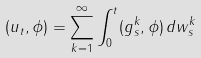Convert formula to latex. <formula><loc_0><loc_0><loc_500><loc_500>( u _ { t } , \phi ) = \sum _ { k = 1 } ^ { \infty } \int _ { 0 } ^ { t } ( g ^ { k } _ { s } , \phi ) \, d w ^ { k } _ { s }</formula> 